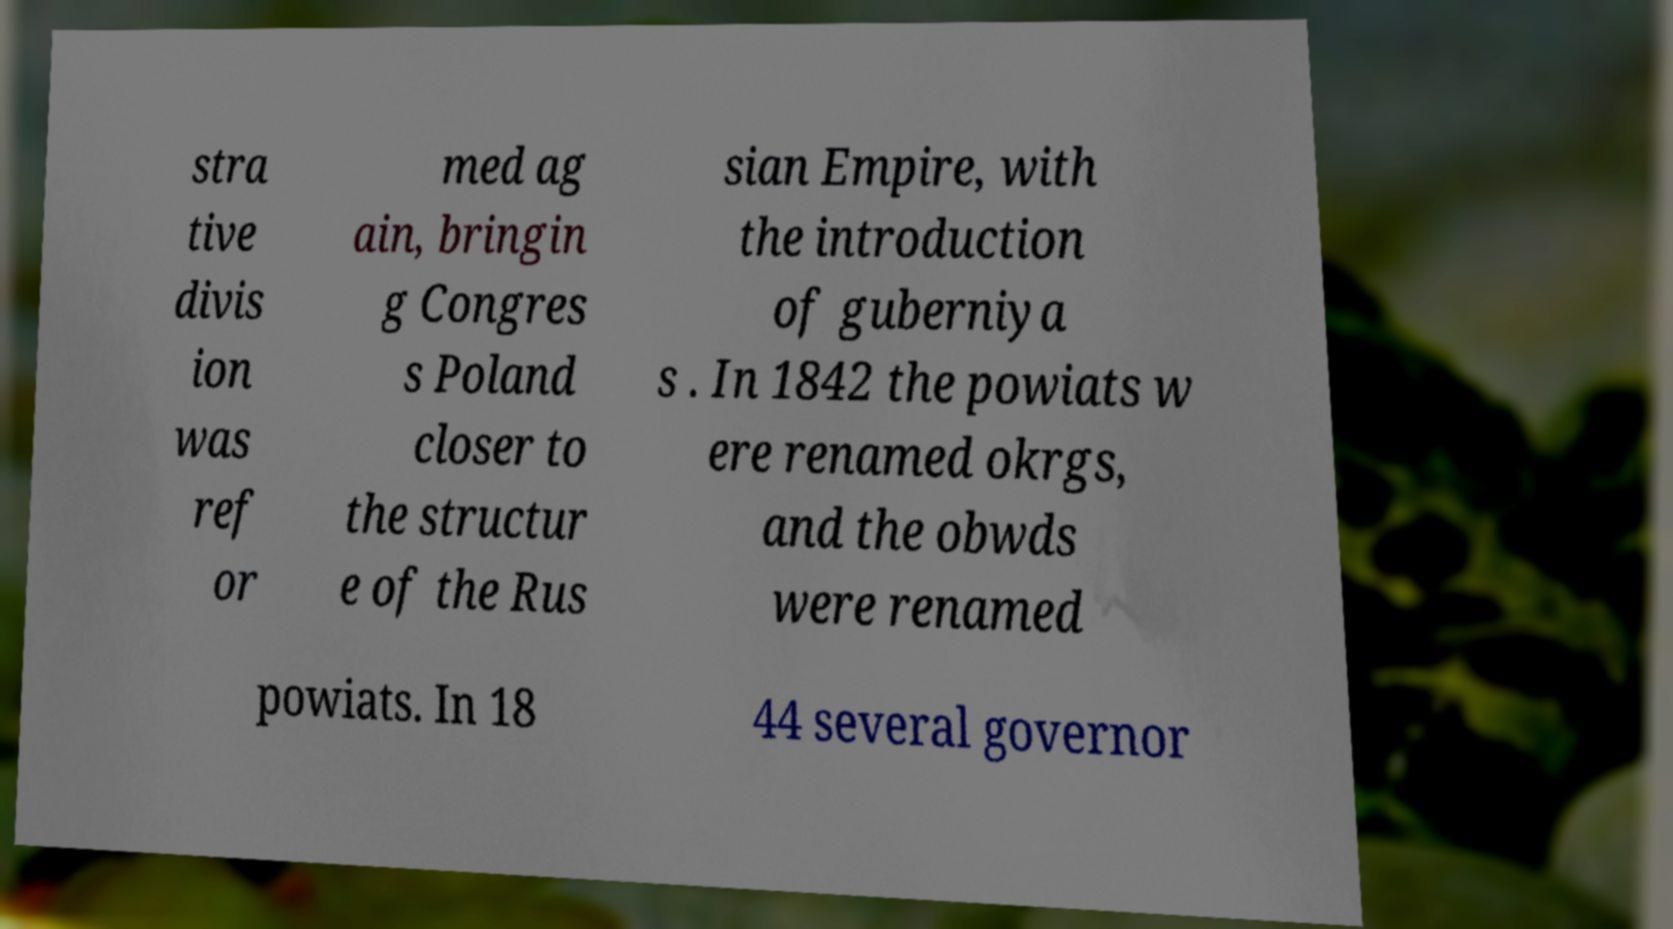I need the written content from this picture converted into text. Can you do that? stra tive divis ion was ref or med ag ain, bringin g Congres s Poland closer to the structur e of the Rus sian Empire, with the introduction of guberniya s . In 1842 the powiats w ere renamed okrgs, and the obwds were renamed powiats. In 18 44 several governor 